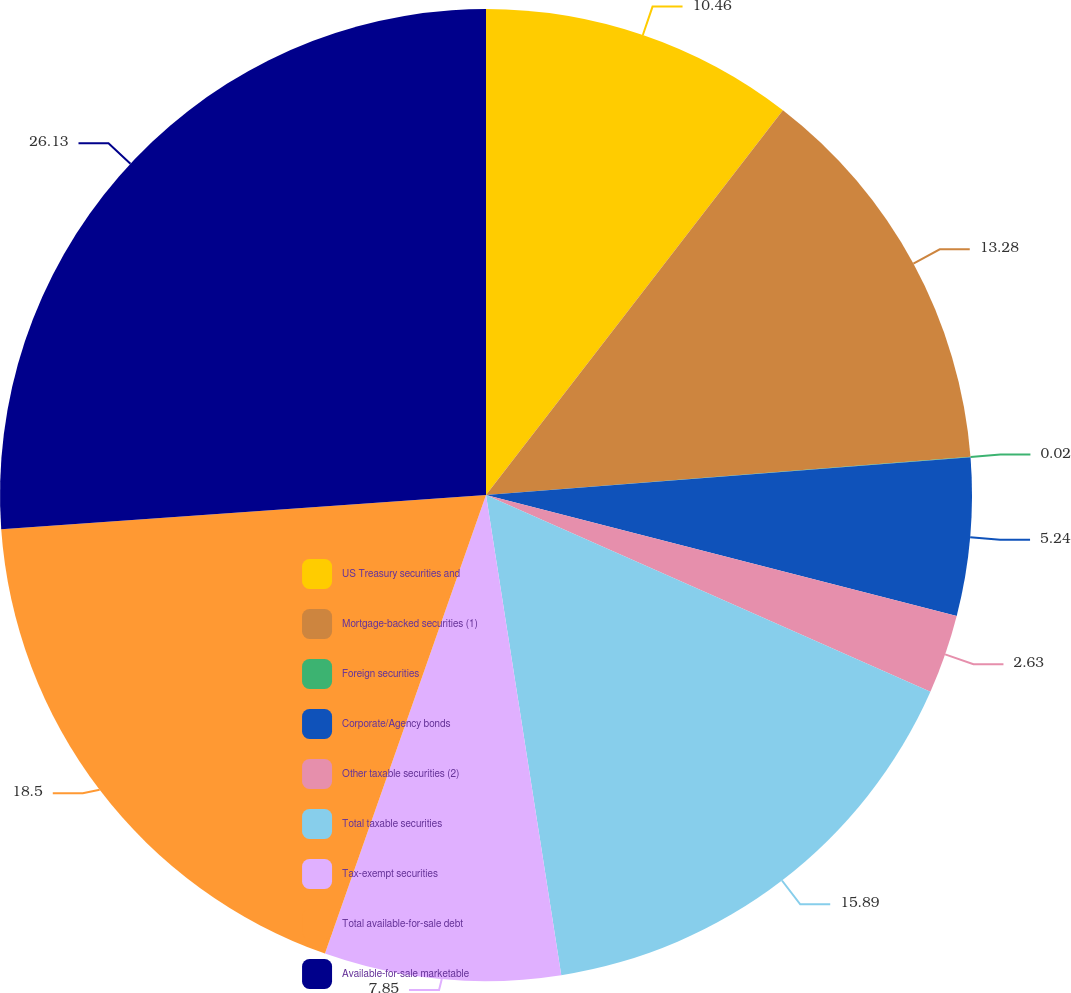Convert chart. <chart><loc_0><loc_0><loc_500><loc_500><pie_chart><fcel>US Treasury securities and<fcel>Mortgage-backed securities (1)<fcel>Foreign securities<fcel>Corporate/Agency bonds<fcel>Other taxable securities (2)<fcel>Total taxable securities<fcel>Tax-exempt securities<fcel>Total available-for-sale debt<fcel>Available-for-sale marketable<nl><fcel>10.46%<fcel>13.28%<fcel>0.02%<fcel>5.24%<fcel>2.63%<fcel>15.89%<fcel>7.85%<fcel>18.5%<fcel>26.12%<nl></chart> 